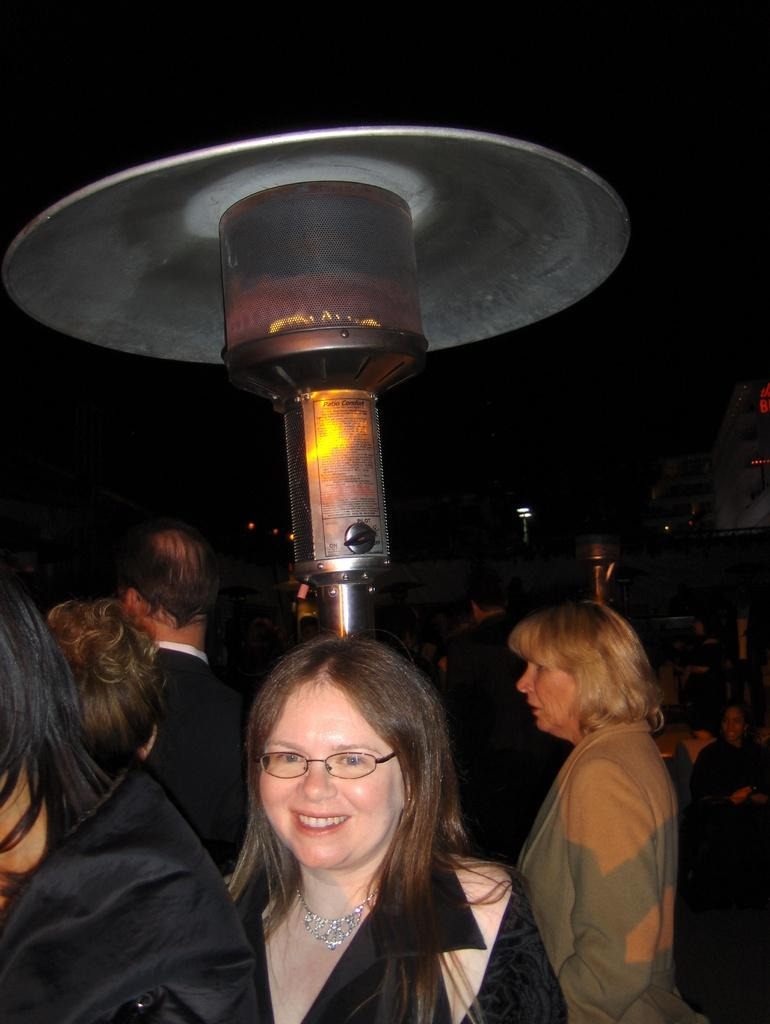What is the main subject of the image? The main subject of the image is a group of people. What can be observed about the clothing of the people in the front? The people in the front are wearing black color dress. Can you describe the lighting or brightness of the image? The image is slightly dark. What type of trail can be seen in the image? There is no trail present in the image; it features a group of people wearing black color dress. What kind of vessel is being used by the people in the image? There is no vessel present in the image; it features a group of people wearing black color dress. 